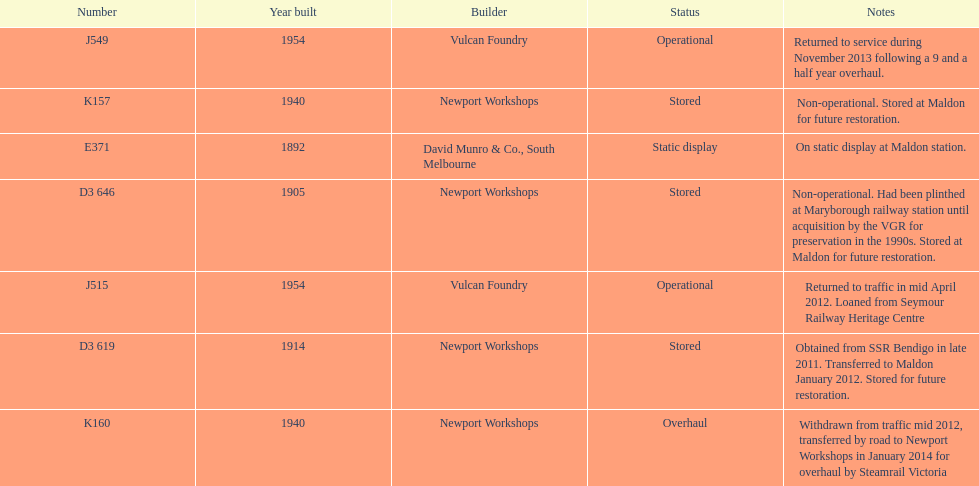How many of the locomotives were built before 1940? 3. 